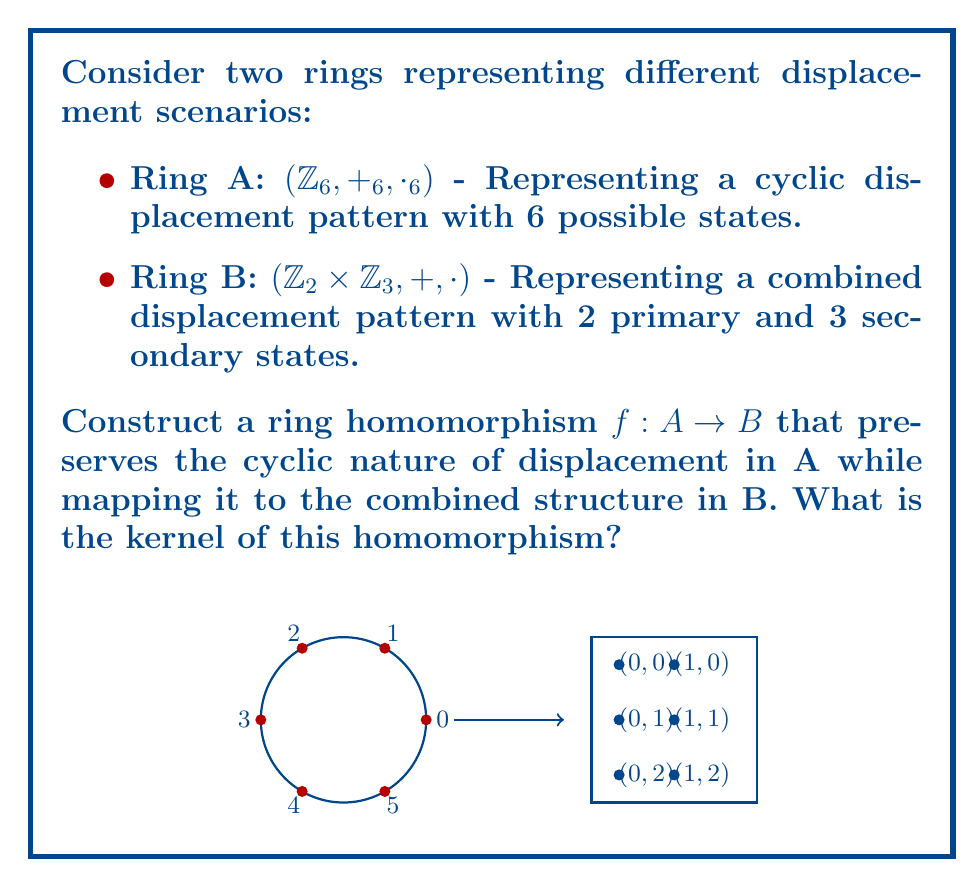Help me with this question. To construct a ring homomorphism $f: A \to B$, we need to ensure that it preserves both addition and multiplication operations. Let's approach this step-by-step:

1) First, we need to define a mapping that preserves the cyclic nature. A natural choice would be:
   $f(0) = (0,0)$, $f(1) = (1,1)$, $f(2) = (0,2)$, $f(3) = (1,0)$, $f(4) = (0,1)$, $f(5) = (1,2)$

2) We need to verify that this mapping preserves addition:
   For example, $f(2 +_6 5) = f(1) = (1,1)$
   And $f(2) + f(5) = (0,2) + (1,2) = (1,1)$

3) We also need to verify that it preserves multiplication:
   For example, $f(2 \cdot_6 3) = f(0) = (0,0)$
   And $f(2) \cdot f(3) = (0,2) \cdot (1,0) = (0,0)$

4) To find the kernel of this homomorphism, we need to identify all elements of A that map to the identity element of B, which is (0,0):
   $\text{ker}(f) = \{a \in A : f(a) = (0,0)\}$

5) From our mapping, we can see that:
   $f(0) = (0,0)$

6) Therefore, the kernel of this homomorphism contains only the zero element of A.
Answer: $\text{ker}(f) = \{0\}$ 